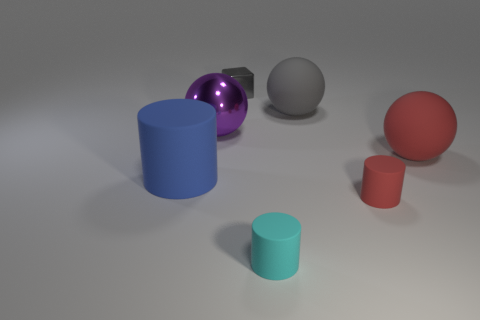Is the number of small purple shiny blocks greater than the number of large red rubber balls?
Offer a terse response. No. What is the material of the small cyan object?
Provide a succinct answer. Rubber. What number of large blue objects are on the left side of the tiny matte object behind the cyan rubber thing?
Your response must be concise. 1. There is a large cylinder; is its color the same as the tiny thing that is behind the big blue cylinder?
Your answer should be very brief. No. What is the color of the cylinder that is the same size as the purple shiny sphere?
Offer a very short reply. Blue. Is there a tiny matte object of the same shape as the large metallic object?
Your response must be concise. No. Are there fewer large blue matte things than things?
Your answer should be compact. Yes. What is the color of the large object in front of the big red sphere?
Ensure brevity in your answer.  Blue. There is a big object that is to the right of the tiny matte cylinder to the right of the tiny cyan rubber cylinder; what shape is it?
Make the answer very short. Sphere. Does the tiny cyan thing have the same material as the big sphere behind the big purple metal ball?
Make the answer very short. Yes. 